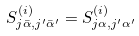Convert formula to latex. <formula><loc_0><loc_0><loc_500><loc_500>S ^ { ( i ) } _ { j \bar { \alpha } , j ^ { \prime } \bar { \alpha } ^ { \prime } } = S ^ { ( i ) } _ { j \alpha , j ^ { \prime } \alpha ^ { \prime } }</formula> 